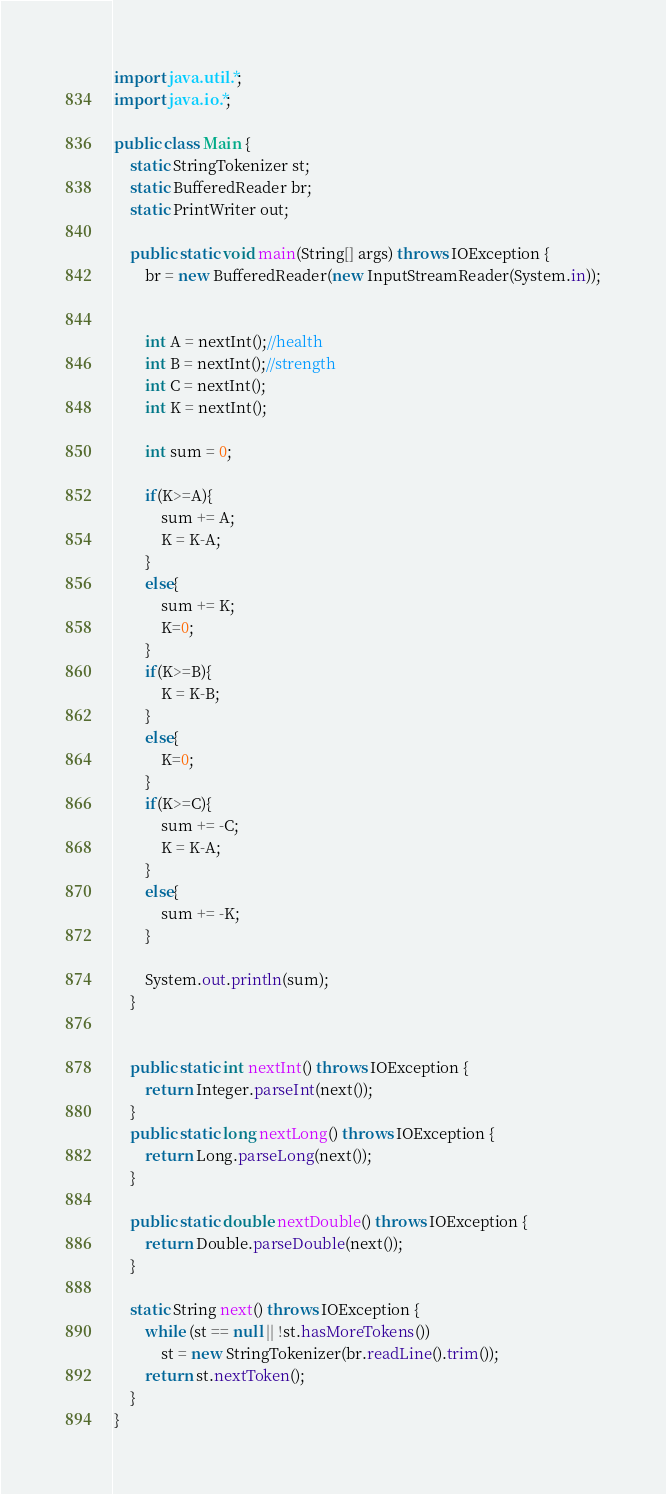Convert code to text. <code><loc_0><loc_0><loc_500><loc_500><_Java_>import java.util.*; 
import java.io.*;

public class Main {
    static StringTokenizer st;
    static BufferedReader br;  
    static PrintWriter out;
 
    public static void main(String[] args) throws IOException {
        br = new BufferedReader(new InputStreamReader(System.in));

        
        int A = nextInt();//health 
        int B = nextInt();//strength 
        int C = nextInt();
        int K = nextInt();
 
        int sum = 0;
  
        if(K>=A){
            sum += A;
            K = K-A;
        }
        else{
            sum += K;
            K=0;
        }
        if(K>=B){  
            K = K-B;
        } 
        else{
            K=0;
        }
        if(K>=C){
            sum += -C;
            K = K-A;
        }
        else{
            sum += -K;
        }
  
        System.out.println(sum);
    }
    
      
    public static int nextInt() throws IOException {
        return Integer.parseInt(next());
    }
    public static long nextLong() throws IOException {
        return Long.parseLong(next());
    }

    public static double nextDouble() throws IOException {
        return Double.parseDouble(next());
    }

    static String next() throws IOException {
        while (st == null || !st.hasMoreTokens())
            st = new StringTokenizer(br.readLine().trim());
        return st.nextToken();
    }
}</code> 